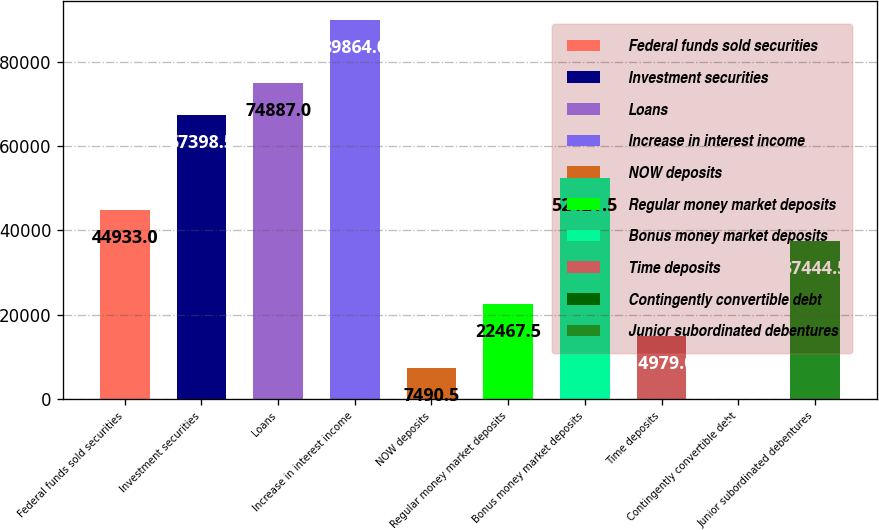Convert chart. <chart><loc_0><loc_0><loc_500><loc_500><bar_chart><fcel>Federal funds sold securities<fcel>Investment securities<fcel>Loans<fcel>Increase in interest income<fcel>NOW deposits<fcel>Regular money market deposits<fcel>Bonus money market deposits<fcel>Time deposits<fcel>Contingently convertible debt<fcel>Junior subordinated debentures<nl><fcel>44933<fcel>67398.5<fcel>74887<fcel>89864<fcel>7490.5<fcel>22467.5<fcel>52421.5<fcel>14979<fcel>2<fcel>37444.5<nl></chart> 